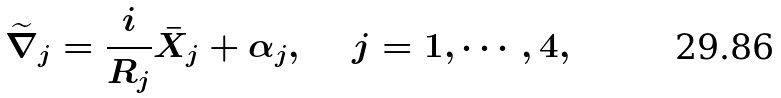Convert formula to latex. <formula><loc_0><loc_0><loc_500><loc_500>\widetilde { \nabla } _ { j } = \frac { i } { R _ { j } } \bar { X } _ { j } + \alpha _ { j } , \text { \quad } j = 1 , \cdots , 4 ,</formula> 